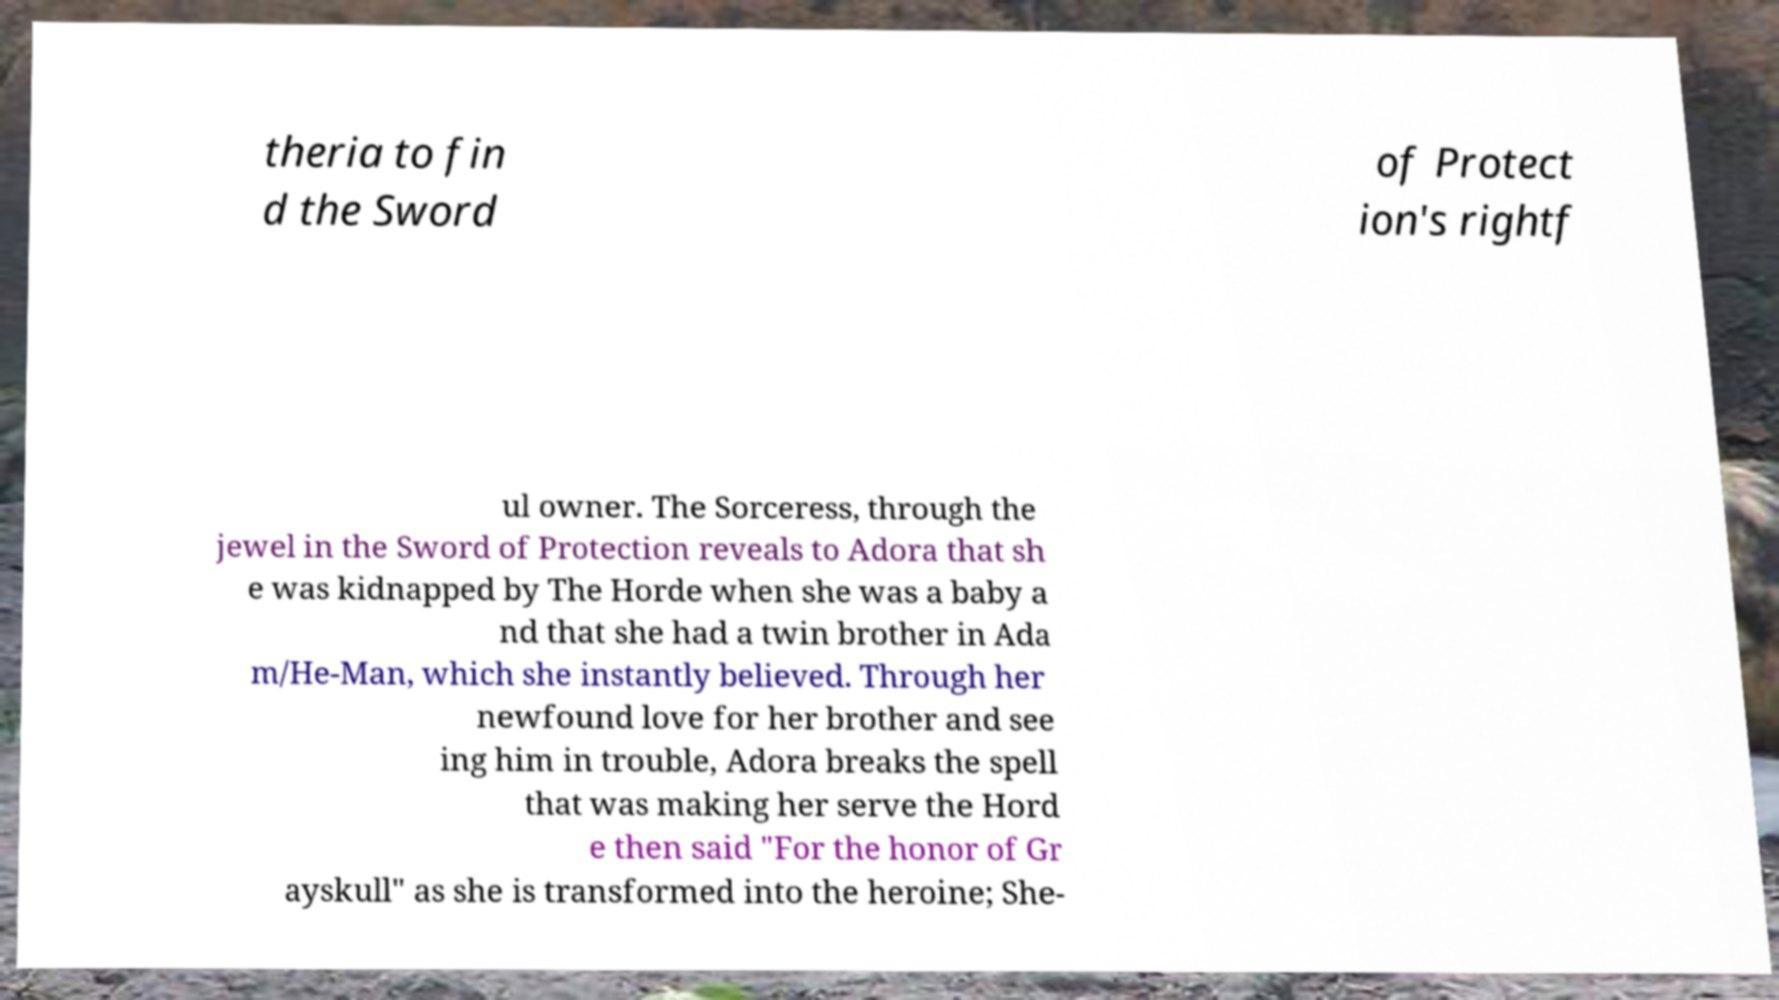For documentation purposes, I need the text within this image transcribed. Could you provide that? theria to fin d the Sword of Protect ion's rightf ul owner. The Sorceress, through the jewel in the Sword of Protection reveals to Adora that sh e was kidnapped by The Horde when she was a baby a nd that she had a twin brother in Ada m/He-Man, which she instantly believed. Through her newfound love for her brother and see ing him in trouble, Adora breaks the spell that was making her serve the Hord e then said "For the honor of Gr ayskull" as she is transformed into the heroine; She- 